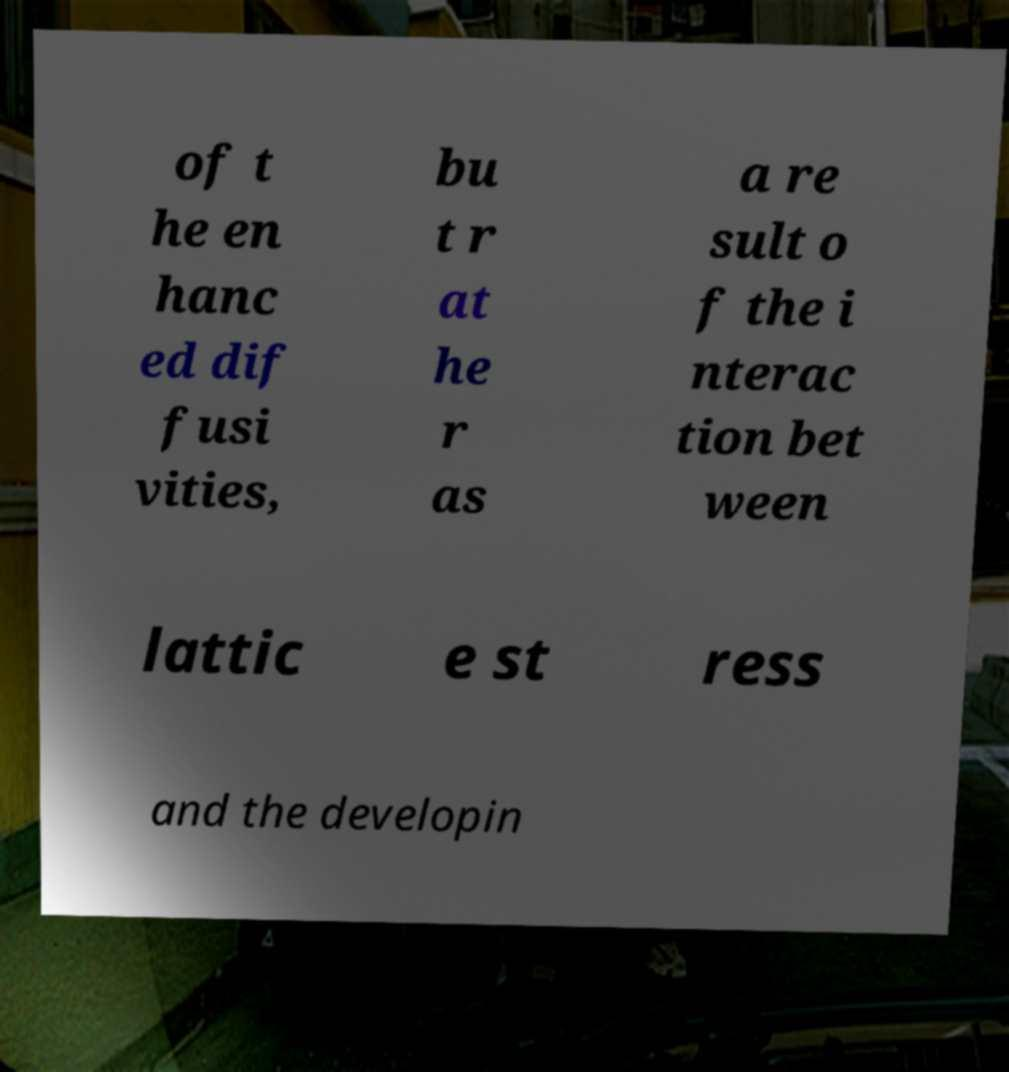Please read and relay the text visible in this image. What does it say? of t he en hanc ed dif fusi vities, bu t r at he r as a re sult o f the i nterac tion bet ween lattic e st ress and the developin 